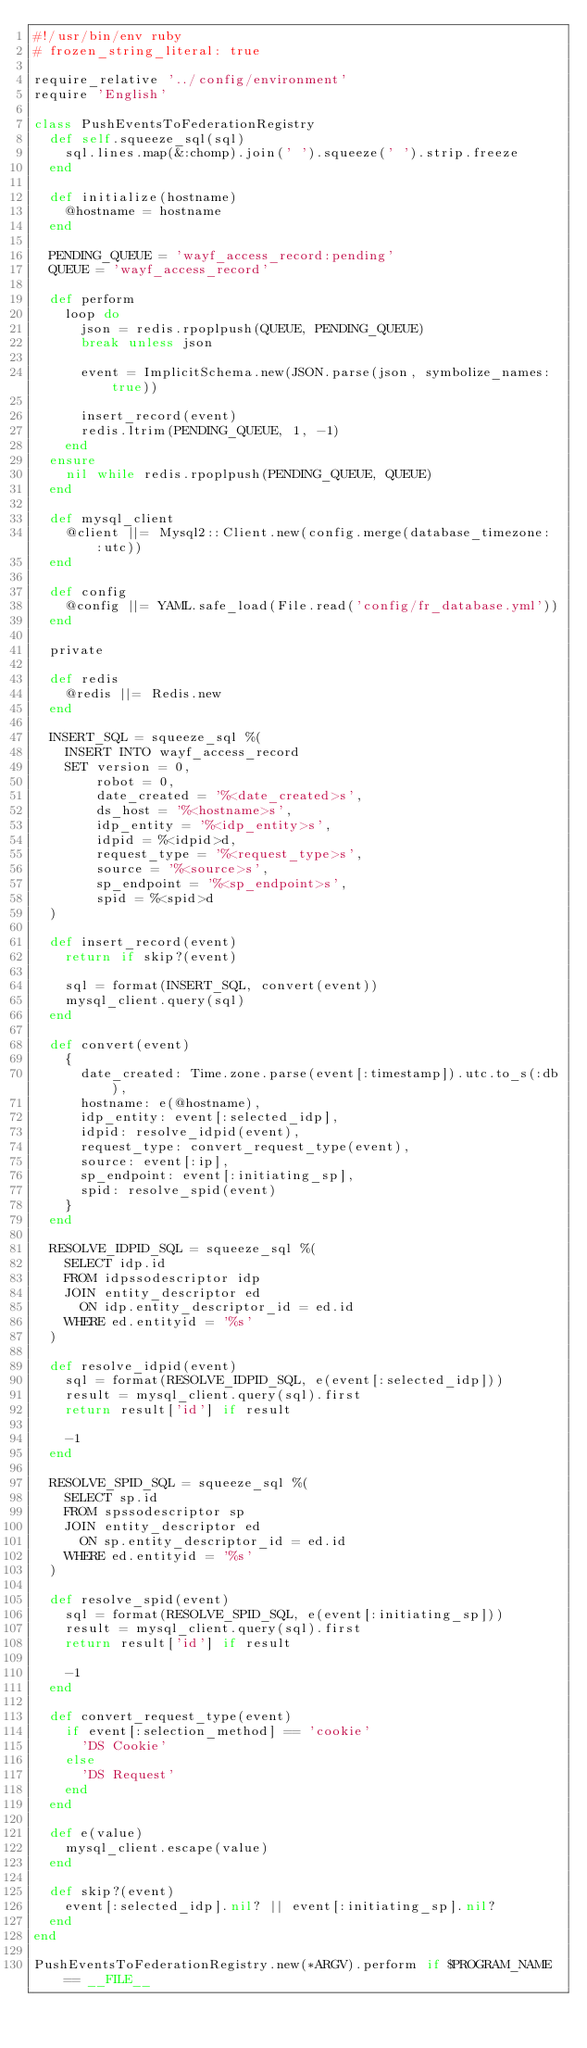<code> <loc_0><loc_0><loc_500><loc_500><_Ruby_>#!/usr/bin/env ruby
# frozen_string_literal: true

require_relative '../config/environment'
require 'English'

class PushEventsToFederationRegistry
  def self.squeeze_sql(sql)
    sql.lines.map(&:chomp).join(' ').squeeze(' ').strip.freeze
  end

  def initialize(hostname)
    @hostname = hostname
  end

  PENDING_QUEUE = 'wayf_access_record:pending'
  QUEUE = 'wayf_access_record'

  def perform
    loop do
      json = redis.rpoplpush(QUEUE, PENDING_QUEUE)
      break unless json

      event = ImplicitSchema.new(JSON.parse(json, symbolize_names: true))

      insert_record(event)
      redis.ltrim(PENDING_QUEUE, 1, -1)
    end
  ensure
    nil while redis.rpoplpush(PENDING_QUEUE, QUEUE)
  end

  def mysql_client
    @client ||= Mysql2::Client.new(config.merge(database_timezone: :utc))
  end

  def config
    @config ||= YAML.safe_load(File.read('config/fr_database.yml'))
  end

  private

  def redis
    @redis ||= Redis.new
  end

  INSERT_SQL = squeeze_sql %(
    INSERT INTO wayf_access_record
    SET version = 0,
        robot = 0,
        date_created = '%<date_created>s',
        ds_host = '%<hostname>s',
        idp_entity = '%<idp_entity>s',
        idpid = %<idpid>d,
        request_type = '%<request_type>s',
        source = '%<source>s',
        sp_endpoint = '%<sp_endpoint>s',
        spid = %<spid>d
  )

  def insert_record(event)
    return if skip?(event)

    sql = format(INSERT_SQL, convert(event))
    mysql_client.query(sql)
  end

  def convert(event)
    {
      date_created: Time.zone.parse(event[:timestamp]).utc.to_s(:db),
      hostname: e(@hostname),
      idp_entity: event[:selected_idp],
      idpid: resolve_idpid(event),
      request_type: convert_request_type(event),
      source: event[:ip],
      sp_endpoint: event[:initiating_sp],
      spid: resolve_spid(event)
    }
  end

  RESOLVE_IDPID_SQL = squeeze_sql %(
    SELECT idp.id
    FROM idpssodescriptor idp
    JOIN entity_descriptor ed
      ON idp.entity_descriptor_id = ed.id
    WHERE ed.entityid = '%s'
  )

  def resolve_idpid(event)
    sql = format(RESOLVE_IDPID_SQL, e(event[:selected_idp]))
    result = mysql_client.query(sql).first
    return result['id'] if result

    -1
  end

  RESOLVE_SPID_SQL = squeeze_sql %(
    SELECT sp.id
    FROM spssodescriptor sp
    JOIN entity_descriptor ed
      ON sp.entity_descriptor_id = ed.id
    WHERE ed.entityid = '%s'
  )

  def resolve_spid(event)
    sql = format(RESOLVE_SPID_SQL, e(event[:initiating_sp]))
    result = mysql_client.query(sql).first
    return result['id'] if result

    -1
  end

  def convert_request_type(event)
    if event[:selection_method] == 'cookie'
      'DS Cookie'
    else
      'DS Request'
    end
  end

  def e(value)
    mysql_client.escape(value)
  end

  def skip?(event)
    event[:selected_idp].nil? || event[:initiating_sp].nil?
  end
end

PushEventsToFederationRegistry.new(*ARGV).perform if $PROGRAM_NAME == __FILE__
</code> 